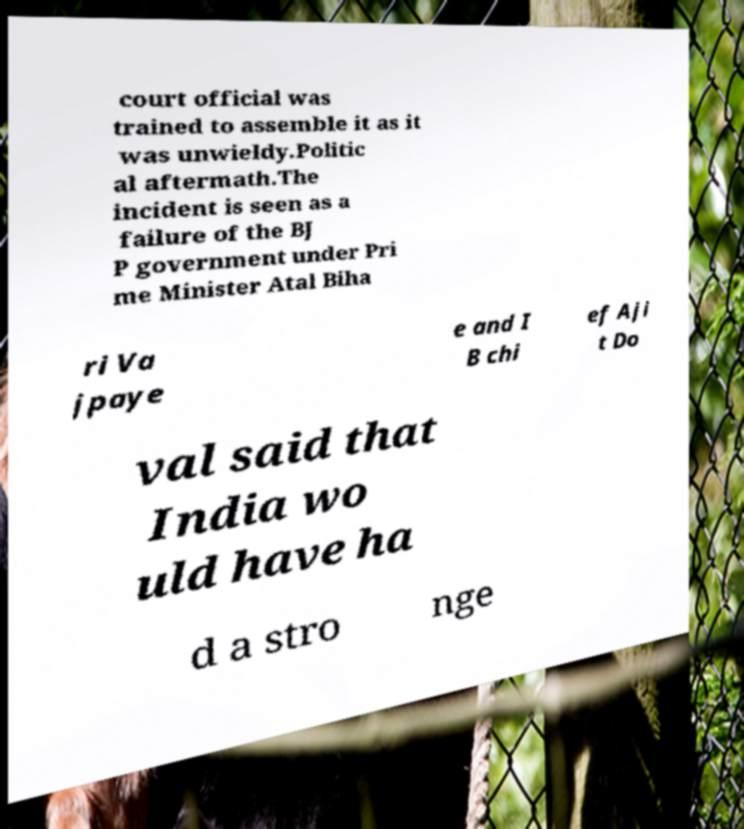Please read and relay the text visible in this image. What does it say? court official was trained to assemble it as it was unwieldy.Politic al aftermath.The incident is seen as a failure of the BJ P government under Pri me Minister Atal Biha ri Va jpaye e and I B chi ef Aji t Do val said that India wo uld have ha d a stro nge 